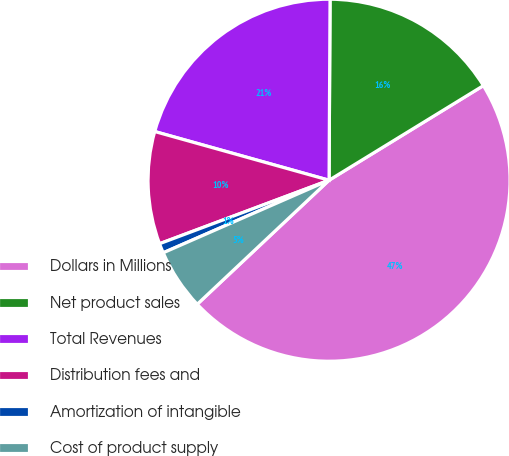Convert chart. <chart><loc_0><loc_0><loc_500><loc_500><pie_chart><fcel>Dollars in Millions<fcel>Net product sales<fcel>Total Revenues<fcel>Distribution fees and<fcel>Amortization of intangible<fcel>Cost of product supply<nl><fcel>46.74%<fcel>16.16%<fcel>20.75%<fcel>10.04%<fcel>0.86%<fcel>5.45%<nl></chart> 